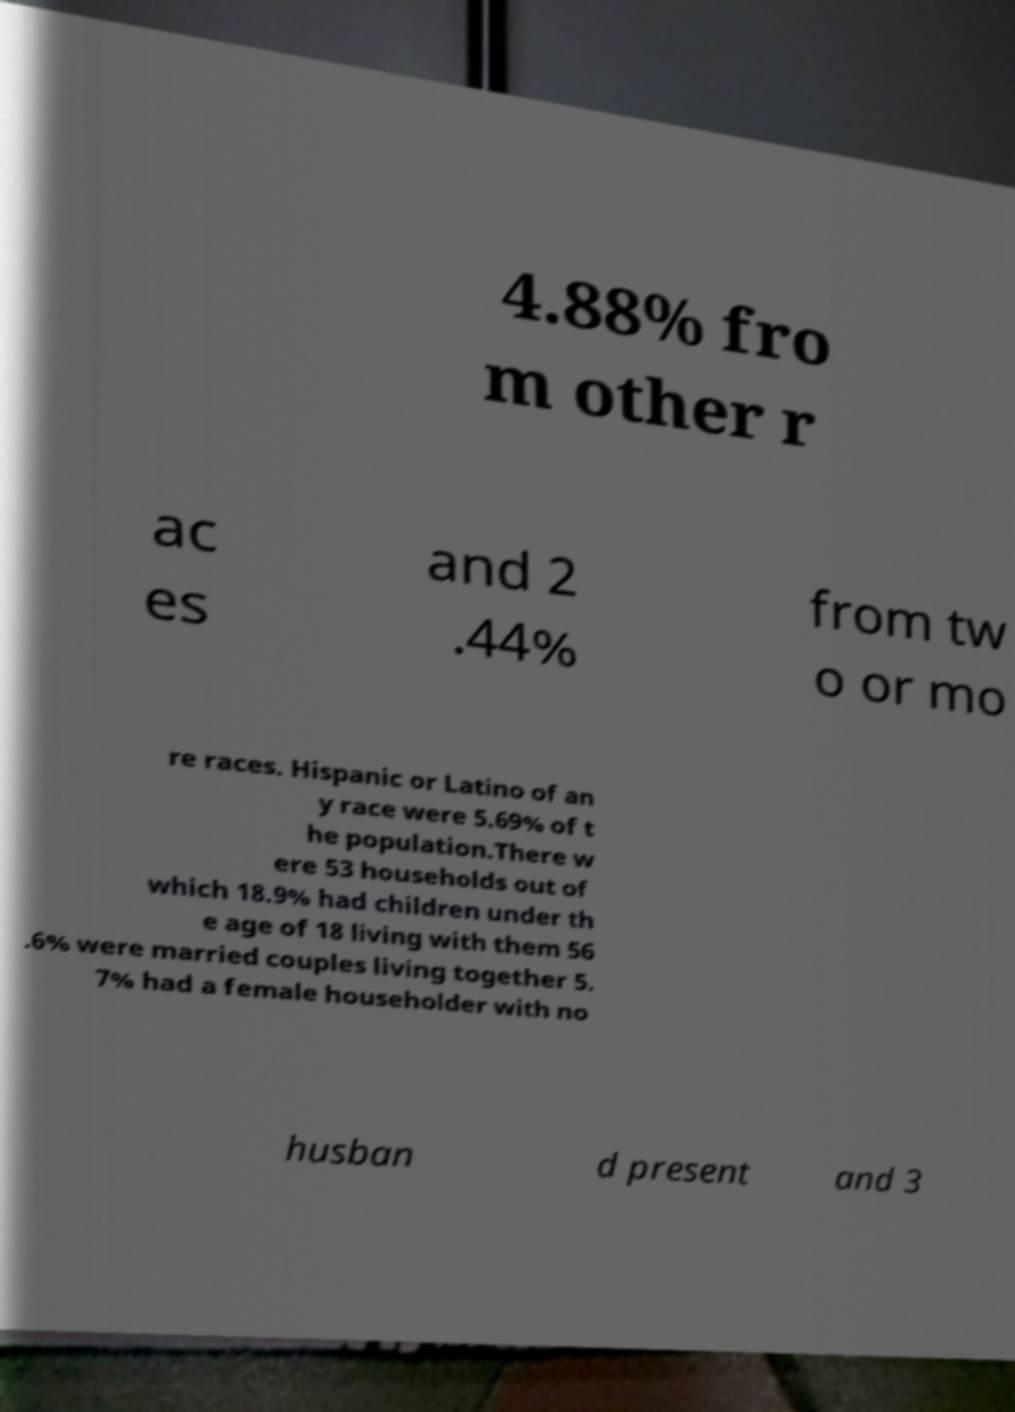There's text embedded in this image that I need extracted. Can you transcribe it verbatim? 4.88% fro m other r ac es and 2 .44% from tw o or mo re races. Hispanic or Latino of an y race were 5.69% of t he population.There w ere 53 households out of which 18.9% had children under th e age of 18 living with them 56 .6% were married couples living together 5. 7% had a female householder with no husban d present and 3 